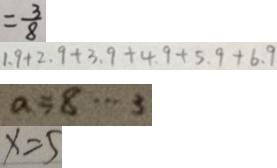Convert formula to latex. <formula><loc_0><loc_0><loc_500><loc_500>= \frac { 3 } { 8 } 
 1 . 9 + 2 . 9 + 3 . 9 + 4 . 9 + 5 . 9 + 6 . 9 
 a = 8 \cdots 3 
 x = 5</formula> 